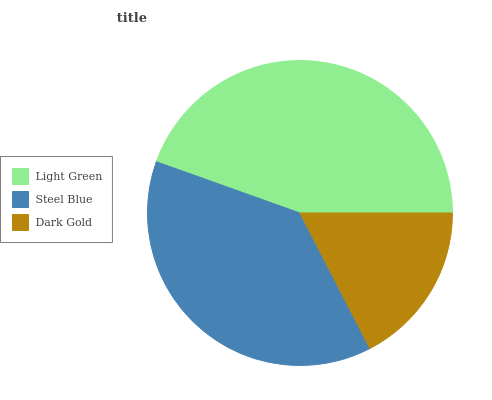Is Dark Gold the minimum?
Answer yes or no. Yes. Is Light Green the maximum?
Answer yes or no. Yes. Is Steel Blue the minimum?
Answer yes or no. No. Is Steel Blue the maximum?
Answer yes or no. No. Is Light Green greater than Steel Blue?
Answer yes or no. Yes. Is Steel Blue less than Light Green?
Answer yes or no. Yes. Is Steel Blue greater than Light Green?
Answer yes or no. No. Is Light Green less than Steel Blue?
Answer yes or no. No. Is Steel Blue the high median?
Answer yes or no. Yes. Is Steel Blue the low median?
Answer yes or no. Yes. Is Dark Gold the high median?
Answer yes or no. No. Is Dark Gold the low median?
Answer yes or no. No. 